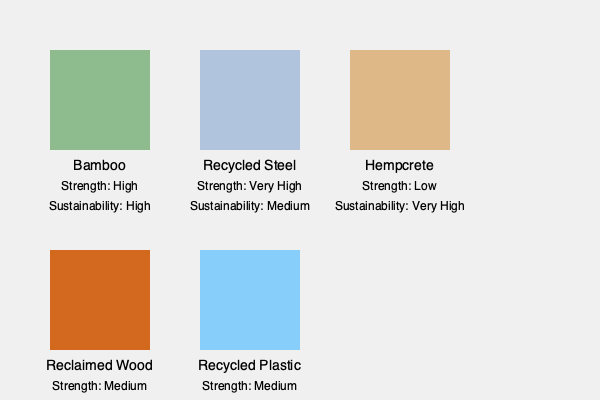Based on the illustration, which sustainable building material would be most suitable for a load-bearing structure in a high-rise building, considering both strength and sustainability? To determine the most suitable material for a load-bearing structure in a high-rise building, we need to consider both strength and sustainability:

1. Bamboo:
   - Strength: High
   - Sustainability: High
   - Good balance, but may not be sufficient for high-rise buildings

2. Recycled Steel:
   - Strength: Very High
   - Sustainability: Medium
   - Best strength, suitable for high-rise buildings

3. Hempcrete:
   - Strength: Low
   - Sustainability: Very High
   - Not suitable for load-bearing structures in high-rise buildings

4. Reclaimed Wood:
   - Strength: Medium
   - Sustainability: High
   - Not strong enough for high-rise buildings

5. Recycled Plastic:
   - Strength: Medium
   - Sustainability: Medium
   - Not strong enough for high-rise buildings

Considering the need for very high strength in a high-rise building, recycled steel is the most suitable option. It offers the highest strength while still maintaining a medium level of sustainability.
Answer: Recycled Steel 